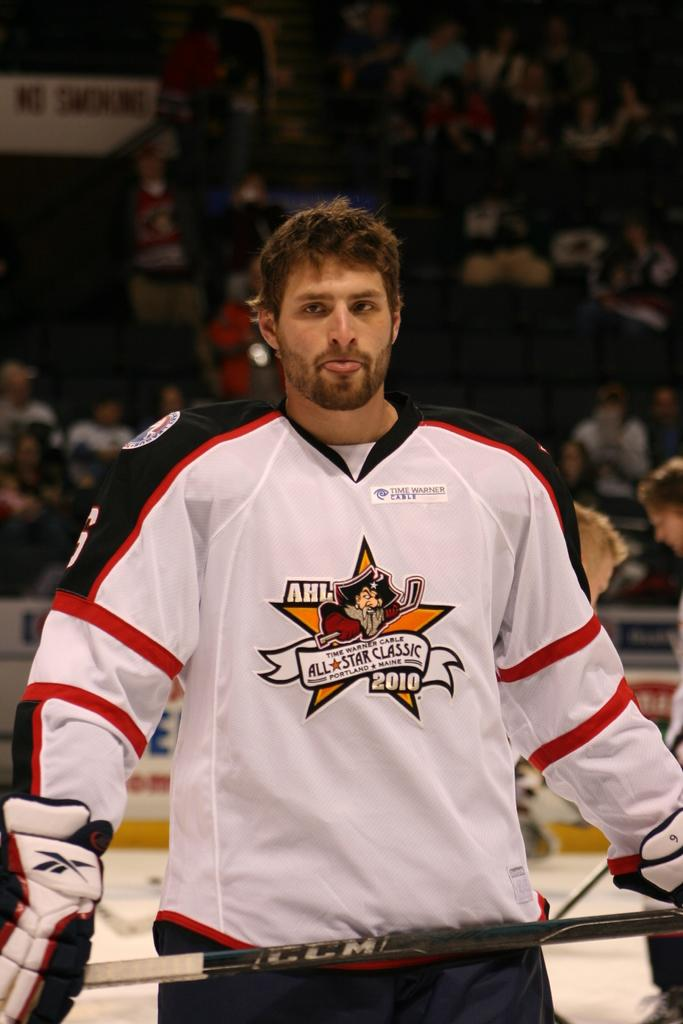Provide a one-sentence caption for the provided image. The hockey player wears an AHL jersey for the All Star Classic. 